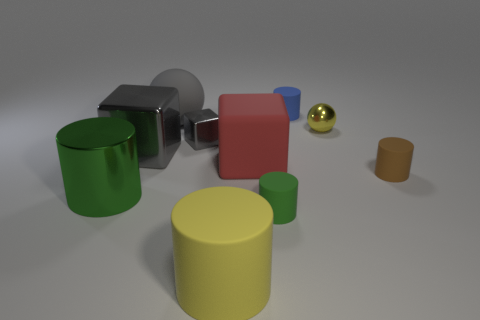Subtract all tiny brown rubber cylinders. How many cylinders are left? 4 Subtract all gray cylinders. How many gray blocks are left? 2 Subtract all red blocks. How many blocks are left? 2 Subtract all balls. How many objects are left? 8 Subtract 1 cylinders. How many cylinders are left? 4 Subtract all gray cylinders. Subtract all blue blocks. How many cylinders are left? 5 Subtract all red objects. Subtract all small matte cylinders. How many objects are left? 6 Add 8 gray balls. How many gray balls are left? 9 Add 3 tiny green things. How many tiny green things exist? 4 Subtract 0 yellow cubes. How many objects are left? 10 